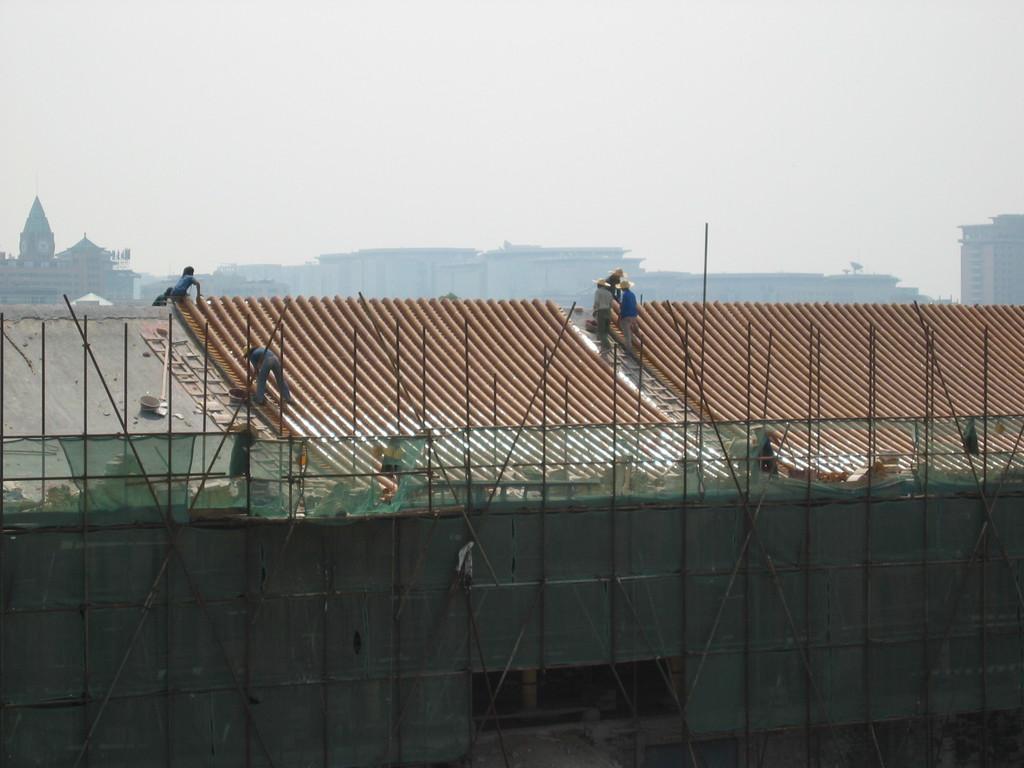Could you give a brief overview of what you see in this image? In the picture we can see a construction of the house, top of it we can see a house with a roof and some people are repairing on it and behind it we can see a temple, some buildings and a sky. 